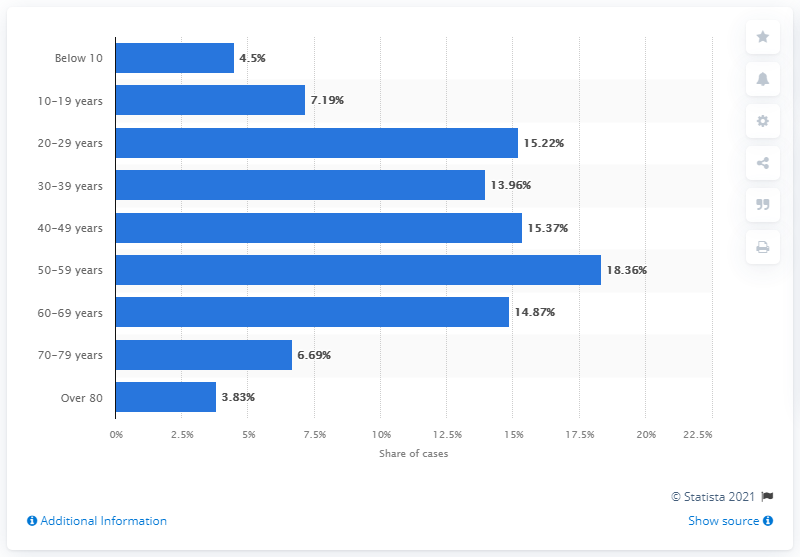Draw attention to some important aspects in this diagram. As of June 24, 2021, a total of 18.36% of COVID-19 patients were in their 50s. 